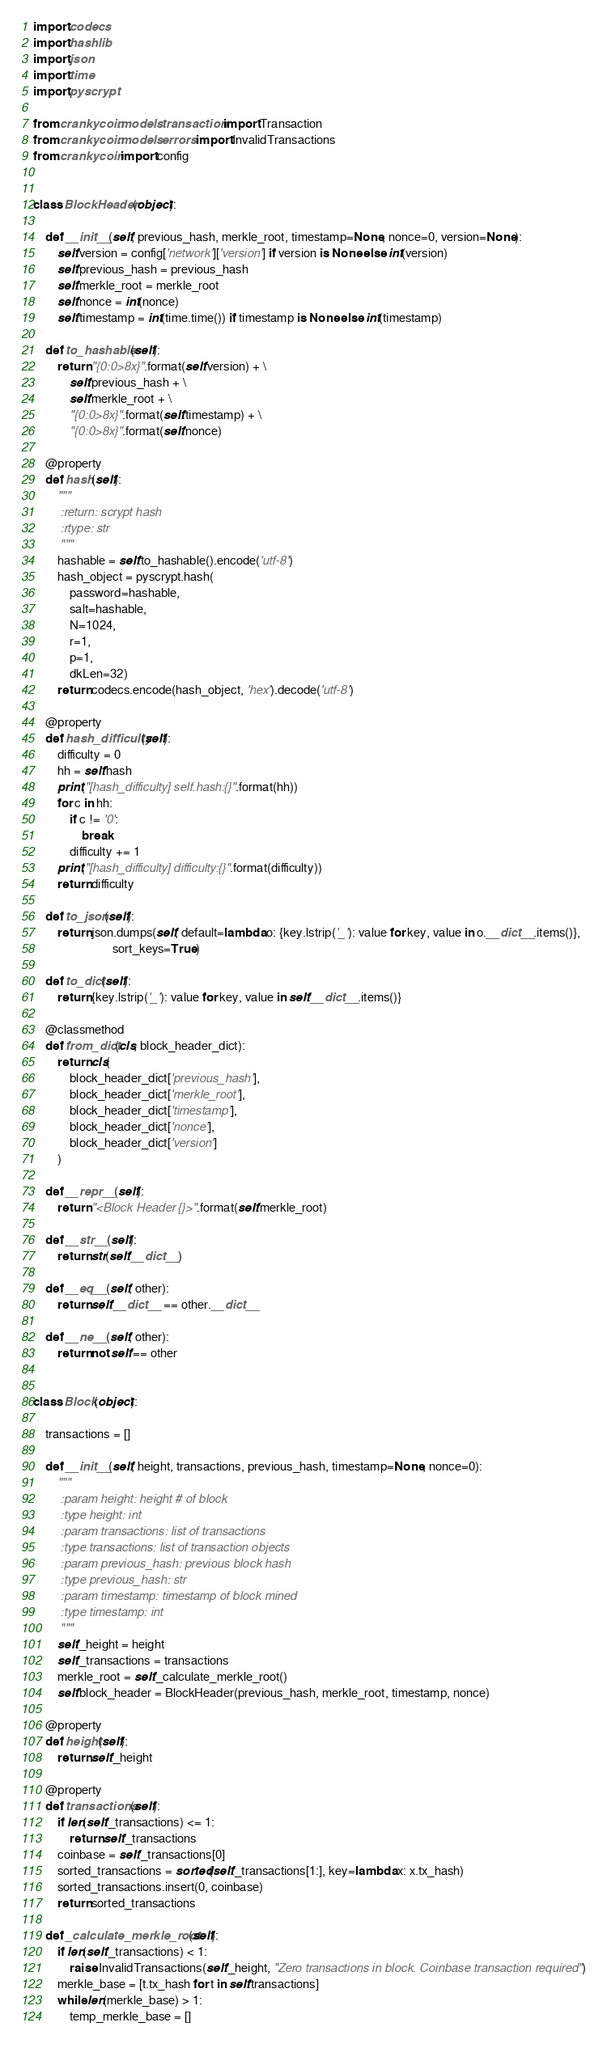<code> <loc_0><loc_0><loc_500><loc_500><_Python_>import codecs
import hashlib
import json
import time
import pyscrypt

from crankycoin.models.transaction import Transaction
from crankycoin.models.errors import InvalidTransactions
from crankycoin import config


class BlockHeader(object):

    def __init__(self, previous_hash, merkle_root, timestamp=None, nonce=0, version=None):
        self.version = config['network']['version'] if version is None else int(version)
        self.previous_hash = previous_hash
        self.merkle_root = merkle_root
        self.nonce = int(nonce)
        self.timestamp = int(time.time()) if timestamp is None else int(timestamp)

    def to_hashable(self):
        return "{0:0>8x}".format(self.version) + \
            self.previous_hash + \
            self.merkle_root + \
            "{0:0>8x}".format(self.timestamp) + \
            "{0:0>8x}".format(self.nonce)

    @property
    def hash(self):
        """
        :return: scrypt hash
        :rtype: str
        """
        hashable = self.to_hashable().encode('utf-8')
        hash_object = pyscrypt.hash(
            password=hashable,
            salt=hashable,
            N=1024,
            r=1,
            p=1,
            dkLen=32)
        return codecs.encode(hash_object, 'hex').decode('utf-8')

    @property
    def hash_difficulty(self):
        difficulty = 0
        hh = self.hash
        print("[hash_difficulty] self.hash:{}".format(hh))
        for c in hh:
            if c != '0':
                break
            difficulty += 1
        print("[hash_difficulty] difficulty:{}".format(difficulty))
        return difficulty

    def to_json(self):
        return json.dumps(self, default=lambda o: {key.lstrip('_'): value for key, value in o.__dict__.items()},
                          sort_keys=True)

    def to_dict(self):
        return {key.lstrip('_'): value for key, value in self.__dict__.items()}

    @classmethod
    def from_dict(cls, block_header_dict):
        return cls(
            block_header_dict['previous_hash'],
            block_header_dict['merkle_root'],
            block_header_dict['timestamp'],
            block_header_dict['nonce'],
            block_header_dict['version']
        )

    def __repr__(self):
        return "<Block Header {}>".format(self.merkle_root)

    def __str__(self):
        return str(self.__dict__)

    def __eq__(self, other):
        return self.__dict__ == other.__dict__

    def __ne__(self, other):
        return not self == other


class Block(object):

    transactions = []

    def __init__(self, height, transactions, previous_hash, timestamp=None, nonce=0):
        """
        :param height: height # of block
        :type height: int
        :param transactions: list of transactions
        :type transactions: list of transaction objects
        :param previous_hash: previous block hash
        :type previous_hash: str
        :param timestamp: timestamp of block mined
        :type timestamp: int
        """
        self._height = height
        self._transactions = transactions
        merkle_root = self._calculate_merkle_root()
        self.block_header = BlockHeader(previous_hash, merkle_root, timestamp, nonce)

    @property
    def height(self):
        return self._height

    @property
    def transactions(self):
        if len(self._transactions) <= 1:
            return self._transactions
        coinbase = self._transactions[0]
        sorted_transactions = sorted(self._transactions[1:], key=lambda x: x.tx_hash)
        sorted_transactions.insert(0, coinbase)
        return sorted_transactions

    def _calculate_merkle_root(self):
        if len(self._transactions) < 1:
            raise InvalidTransactions(self._height, "Zero transactions in block. Coinbase transaction required")
        merkle_base = [t.tx_hash for t in self.transactions]
        while len(merkle_base) > 1:
            temp_merkle_base = []</code> 